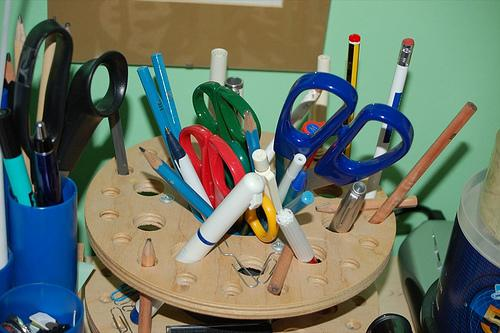Question: what is the stuff on?
Choices:
A. Desk.
B. End table.
C. Dresser.
D. Floor.
Answer with the letter. Answer: A 